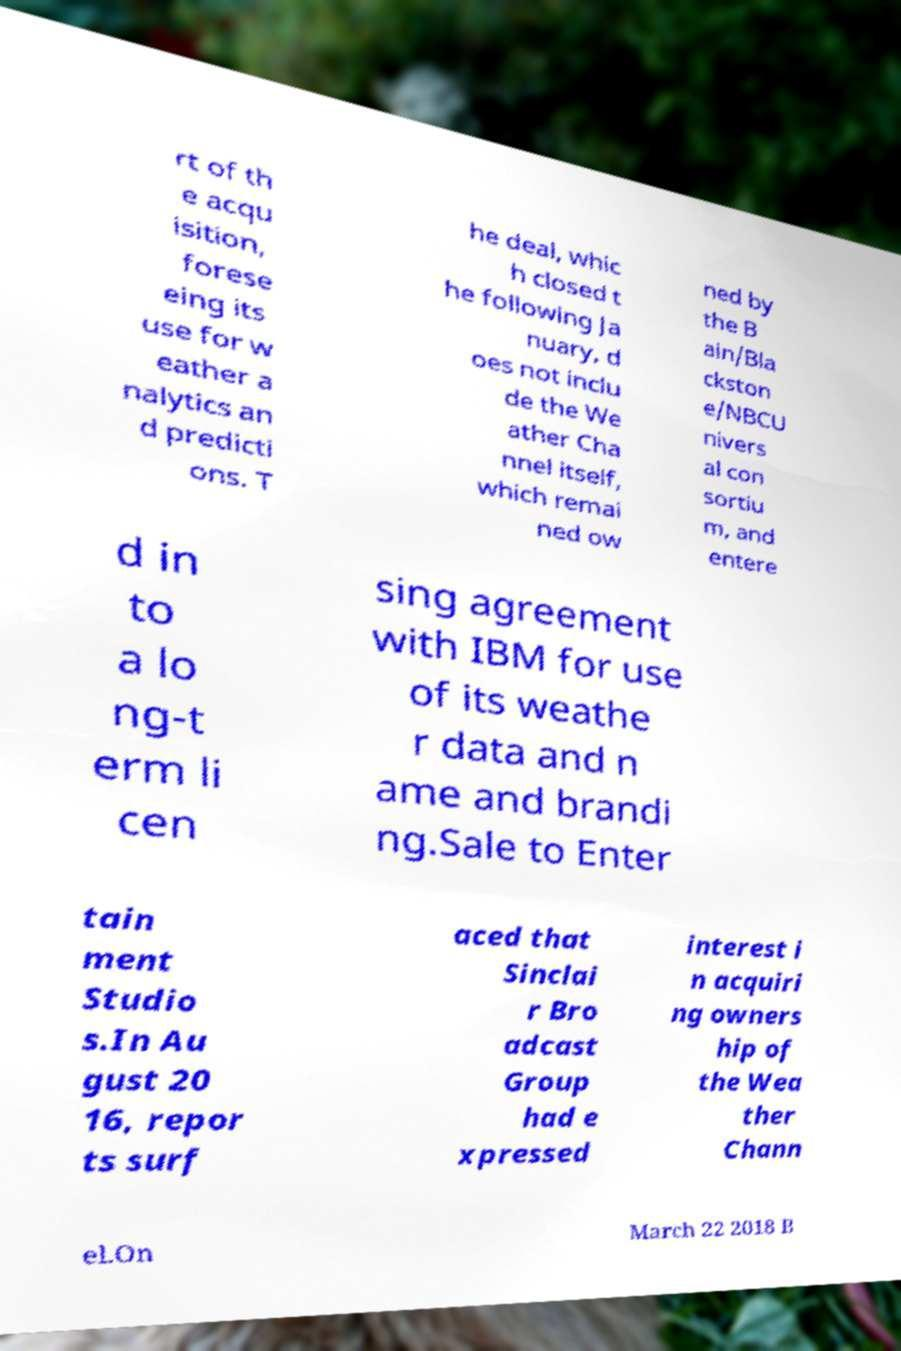Please read and relay the text visible in this image. What does it say? rt of th e acqu isition, forese eing its use for w eather a nalytics an d predicti ons. T he deal, whic h closed t he following Ja nuary, d oes not inclu de the We ather Cha nnel itself, which remai ned ow ned by the B ain/Bla ckston e/NBCU nivers al con sortiu m, and entere d in to a lo ng-t erm li cen sing agreement with IBM for use of its weathe r data and n ame and brandi ng.Sale to Enter tain ment Studio s.In Au gust 20 16, repor ts surf aced that Sinclai r Bro adcast Group had e xpressed interest i n acquiri ng owners hip of the Wea ther Chann el.On March 22 2018 B 